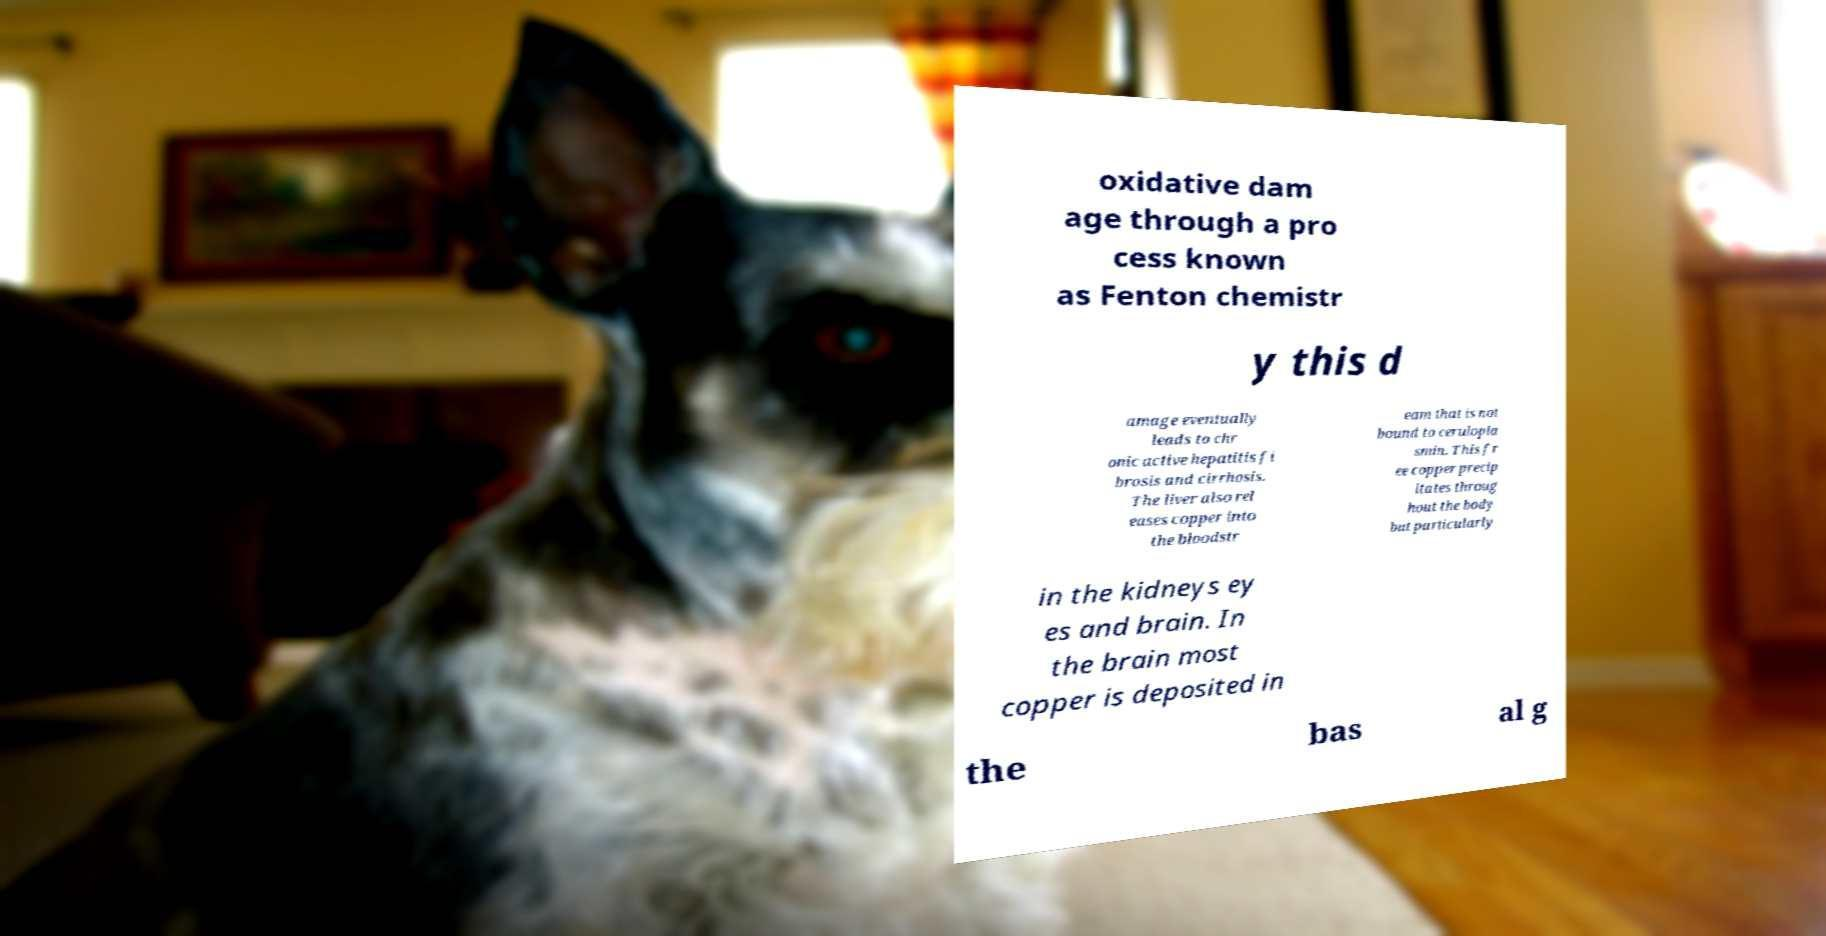What messages or text are displayed in this image? I need them in a readable, typed format. oxidative dam age through a pro cess known as Fenton chemistr y this d amage eventually leads to chr onic active hepatitis fi brosis and cirrhosis. The liver also rel eases copper into the bloodstr eam that is not bound to cerulopla smin. This fr ee copper precip itates throug hout the body but particularly in the kidneys ey es and brain. In the brain most copper is deposited in the bas al g 